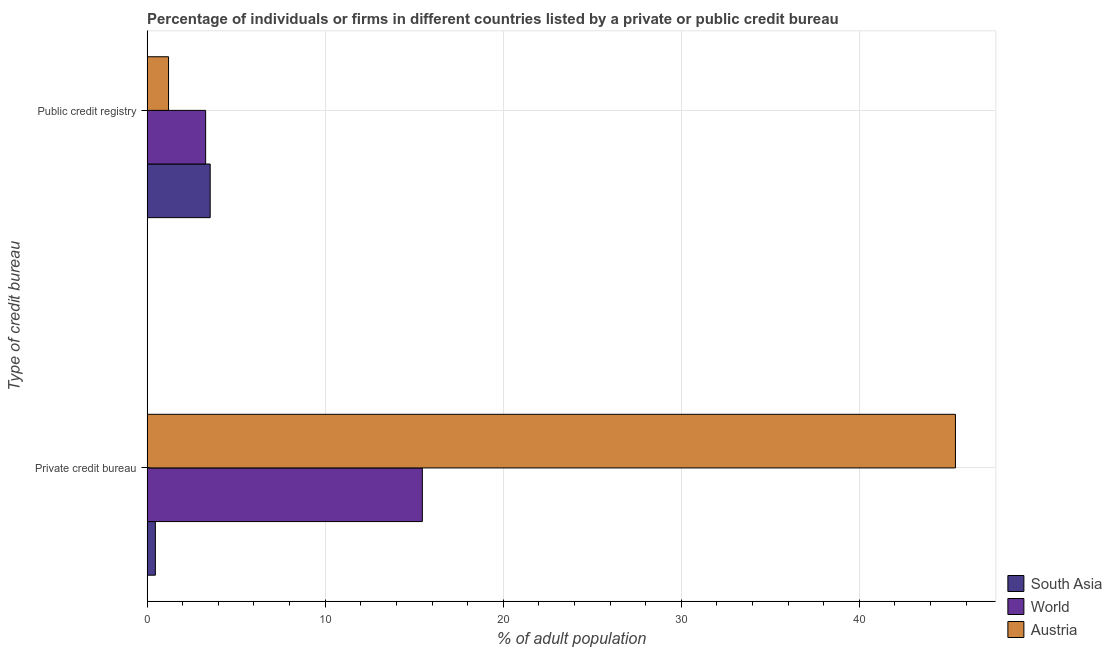How many different coloured bars are there?
Your answer should be compact. 3. How many groups of bars are there?
Offer a very short reply. 2. Are the number of bars per tick equal to the number of legend labels?
Offer a very short reply. Yes. Are the number of bars on each tick of the Y-axis equal?
Offer a very short reply. Yes. How many bars are there on the 2nd tick from the top?
Offer a very short reply. 3. What is the label of the 2nd group of bars from the top?
Your response must be concise. Private credit bureau. What is the percentage of firms listed by private credit bureau in South Asia?
Give a very brief answer. 0.46. Across all countries, what is the maximum percentage of firms listed by private credit bureau?
Keep it short and to the point. 45.4. Across all countries, what is the minimum percentage of firms listed by private credit bureau?
Provide a succinct answer. 0.46. What is the total percentage of firms listed by private credit bureau in the graph?
Provide a succinct answer. 61.32. What is the difference between the percentage of firms listed by public credit bureau in World and that in South Asia?
Offer a terse response. -0.26. What is the difference between the percentage of firms listed by private credit bureau in Austria and the percentage of firms listed by public credit bureau in South Asia?
Give a very brief answer. 41.86. What is the average percentage of firms listed by private credit bureau per country?
Offer a terse response. 20.44. What is the difference between the percentage of firms listed by public credit bureau and percentage of firms listed by private credit bureau in World?
Make the answer very short. -12.17. What is the ratio of the percentage of firms listed by private credit bureau in Austria to that in South Asia?
Provide a succinct answer. 98.7. In how many countries, is the percentage of firms listed by private credit bureau greater than the average percentage of firms listed by private credit bureau taken over all countries?
Provide a succinct answer. 1. What does the 1st bar from the top in Private credit bureau represents?
Your answer should be compact. Austria. What does the 3rd bar from the bottom in Private credit bureau represents?
Your answer should be very brief. Austria. Are all the bars in the graph horizontal?
Give a very brief answer. Yes. What is the difference between two consecutive major ticks on the X-axis?
Your answer should be compact. 10. Are the values on the major ticks of X-axis written in scientific E-notation?
Provide a succinct answer. No. Does the graph contain any zero values?
Ensure brevity in your answer.  No. How many legend labels are there?
Your response must be concise. 3. How are the legend labels stacked?
Provide a short and direct response. Vertical. What is the title of the graph?
Provide a short and direct response. Percentage of individuals or firms in different countries listed by a private or public credit bureau. Does "Sweden" appear as one of the legend labels in the graph?
Provide a succinct answer. No. What is the label or title of the X-axis?
Give a very brief answer. % of adult population. What is the label or title of the Y-axis?
Ensure brevity in your answer.  Type of credit bureau. What is the % of adult population of South Asia in Private credit bureau?
Your answer should be compact. 0.46. What is the % of adult population in World in Private credit bureau?
Provide a succinct answer. 15.46. What is the % of adult population in Austria in Private credit bureau?
Make the answer very short. 45.4. What is the % of adult population in South Asia in Public credit registry?
Your answer should be very brief. 3.54. What is the % of adult population of World in Public credit registry?
Give a very brief answer. 3.28. What is the % of adult population in Austria in Public credit registry?
Make the answer very short. 1.2. Across all Type of credit bureau, what is the maximum % of adult population in South Asia?
Keep it short and to the point. 3.54. Across all Type of credit bureau, what is the maximum % of adult population in World?
Provide a succinct answer. 15.46. Across all Type of credit bureau, what is the maximum % of adult population of Austria?
Offer a terse response. 45.4. Across all Type of credit bureau, what is the minimum % of adult population of South Asia?
Give a very brief answer. 0.46. Across all Type of credit bureau, what is the minimum % of adult population in World?
Keep it short and to the point. 3.28. What is the total % of adult population of South Asia in the graph?
Keep it short and to the point. 4. What is the total % of adult population of World in the graph?
Your answer should be very brief. 18.74. What is the total % of adult population in Austria in the graph?
Make the answer very short. 46.6. What is the difference between the % of adult population in South Asia in Private credit bureau and that in Public credit registry?
Your answer should be compact. -3.08. What is the difference between the % of adult population in World in Private credit bureau and that in Public credit registry?
Keep it short and to the point. 12.17. What is the difference between the % of adult population in Austria in Private credit bureau and that in Public credit registry?
Keep it short and to the point. 44.2. What is the difference between the % of adult population of South Asia in Private credit bureau and the % of adult population of World in Public credit registry?
Offer a terse response. -2.82. What is the difference between the % of adult population in South Asia in Private credit bureau and the % of adult population in Austria in Public credit registry?
Your response must be concise. -0.74. What is the difference between the % of adult population of World in Private credit bureau and the % of adult population of Austria in Public credit registry?
Keep it short and to the point. 14.26. What is the average % of adult population in South Asia per Type of credit bureau?
Your answer should be compact. 2. What is the average % of adult population of World per Type of credit bureau?
Keep it short and to the point. 9.37. What is the average % of adult population in Austria per Type of credit bureau?
Ensure brevity in your answer.  23.3. What is the difference between the % of adult population of South Asia and % of adult population of World in Private credit bureau?
Make the answer very short. -15. What is the difference between the % of adult population of South Asia and % of adult population of Austria in Private credit bureau?
Make the answer very short. -44.94. What is the difference between the % of adult population in World and % of adult population in Austria in Private credit bureau?
Provide a short and direct response. -29.94. What is the difference between the % of adult population of South Asia and % of adult population of World in Public credit registry?
Make the answer very short. 0.26. What is the difference between the % of adult population in South Asia and % of adult population in Austria in Public credit registry?
Offer a terse response. 2.34. What is the difference between the % of adult population in World and % of adult population in Austria in Public credit registry?
Offer a terse response. 2.08. What is the ratio of the % of adult population of South Asia in Private credit bureau to that in Public credit registry?
Provide a short and direct response. 0.13. What is the ratio of the % of adult population in World in Private credit bureau to that in Public credit registry?
Ensure brevity in your answer.  4.71. What is the ratio of the % of adult population in Austria in Private credit bureau to that in Public credit registry?
Provide a short and direct response. 37.83. What is the difference between the highest and the second highest % of adult population in South Asia?
Your answer should be compact. 3.08. What is the difference between the highest and the second highest % of adult population in World?
Keep it short and to the point. 12.17. What is the difference between the highest and the second highest % of adult population in Austria?
Your response must be concise. 44.2. What is the difference between the highest and the lowest % of adult population of South Asia?
Make the answer very short. 3.08. What is the difference between the highest and the lowest % of adult population of World?
Your response must be concise. 12.17. What is the difference between the highest and the lowest % of adult population of Austria?
Your answer should be compact. 44.2. 